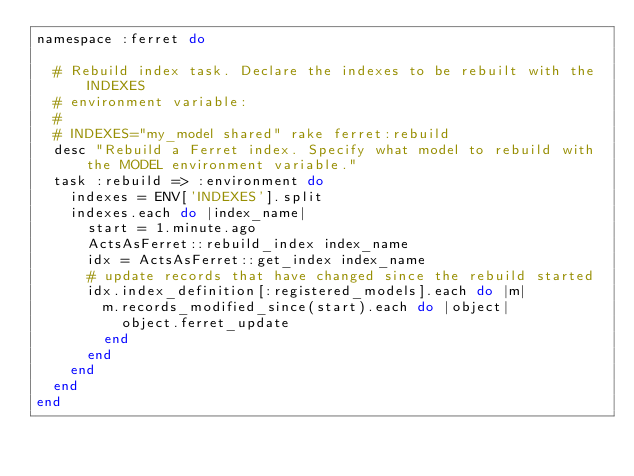Convert code to text. <code><loc_0><loc_0><loc_500><loc_500><_Ruby_>namespace :ferret do

  # Rebuild index task. Declare the indexes to be rebuilt with the INDEXES
  # environment variable:
  #
  # INDEXES="my_model shared" rake ferret:rebuild
  desc "Rebuild a Ferret index. Specify what model to rebuild with the MODEL environment variable."
  task :rebuild => :environment do
    indexes = ENV['INDEXES'].split
    indexes.each do |index_name|
      start = 1.minute.ago
      ActsAsFerret::rebuild_index index_name
      idx = ActsAsFerret::get_index index_name
      # update records that have changed since the rebuild started
      idx.index_definition[:registered_models].each do |m|
        m.records_modified_since(start).each do |object|
          object.ferret_update
        end
      end
    end
  end
end
</code> 